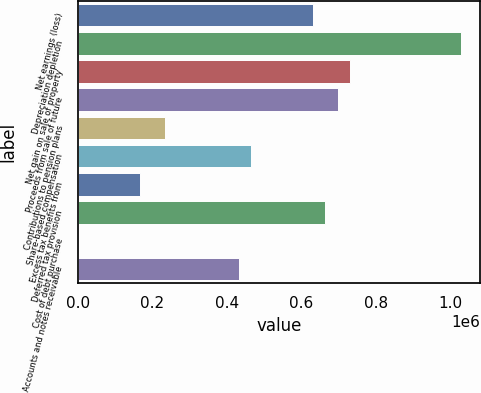<chart> <loc_0><loc_0><loc_500><loc_500><bar_chart><fcel>Net earnings (loss)<fcel>Depreciation depletion<fcel>Net gain on sale of property<fcel>Proceeds from sale of future<fcel>Contributions to pension plans<fcel>Share-based compensation<fcel>Excess tax benefits from<fcel>Deferred tax provision<fcel>Cost of debt purchase<fcel>Accounts and notes receivable<nl><fcel>630720<fcel>1.02907e+06<fcel>730307<fcel>697112<fcel>232372<fcel>464742<fcel>165981<fcel>663916<fcel>2.11<fcel>431546<nl></chart> 